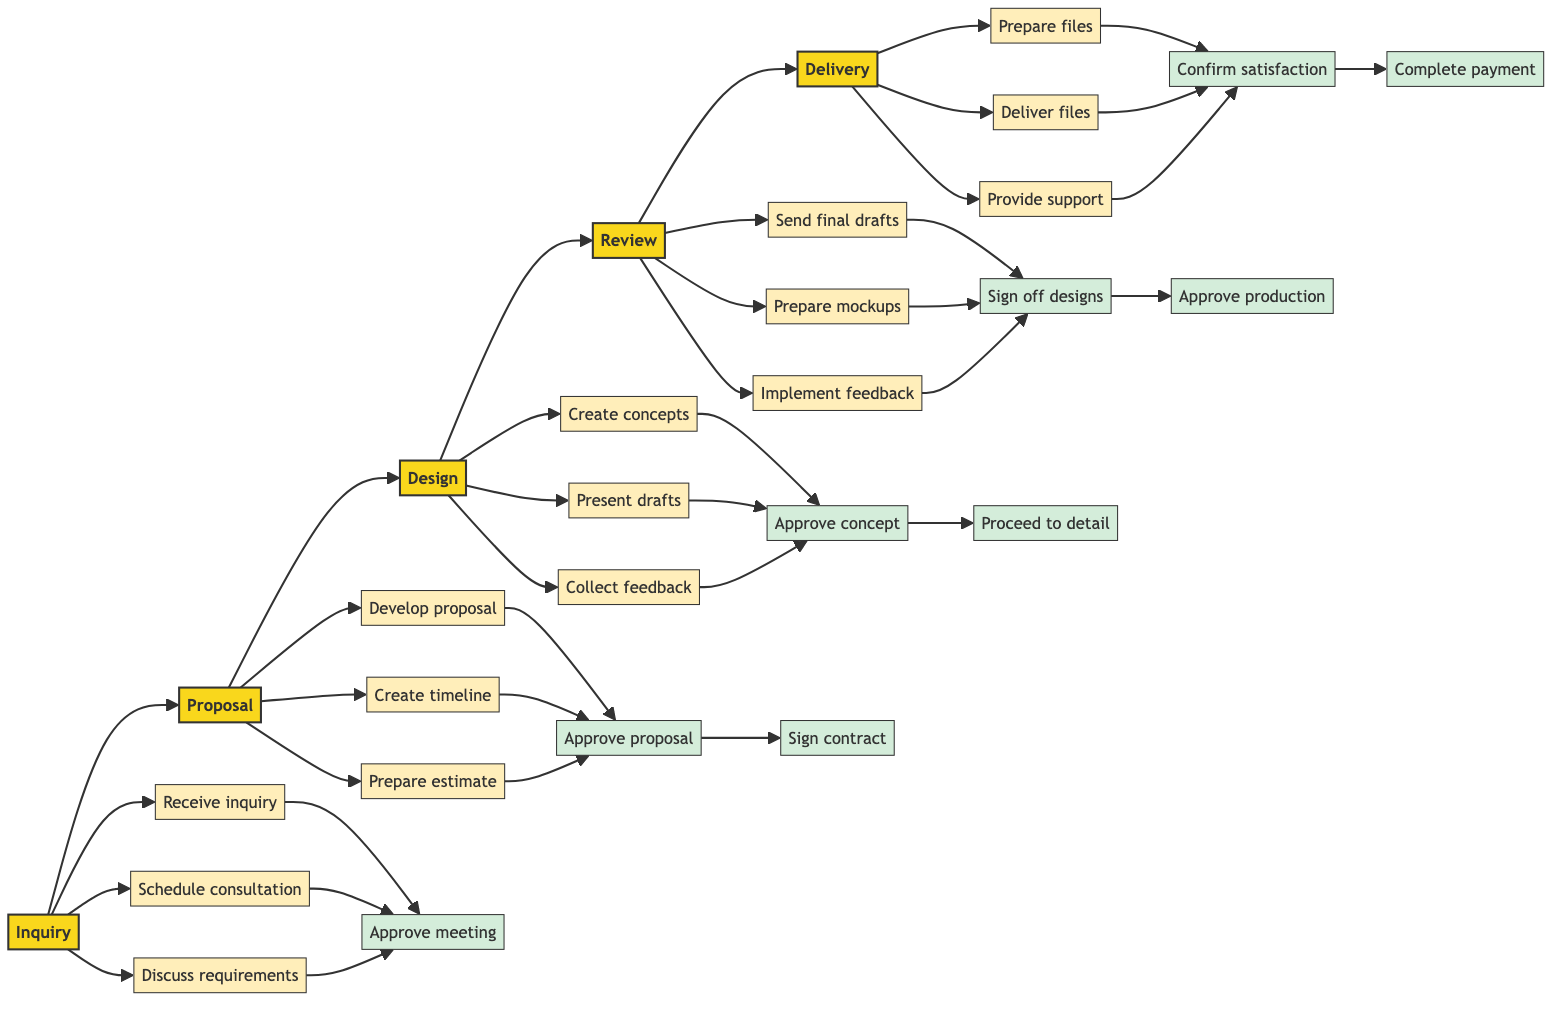What is the first stage in the workflow? The first stage is indicated as "Inquiry" in the flowchart, which is the starting point of the client project workflow.
Answer: Inquiry How many key tasks are there in the Proposal stage? In the Proposal stage, there are three key tasks listed: Develop project proposal, Create project timeline, and Prepare cost estimate. Thus, the total count is three.
Answer: 3 What approval comes after creating design concepts? The approval following the creation of design concepts is the "Client approves final design concept," which allows for proceeding with detailed design work.
Answer: Client approves final design concept Which stage involves preparing mockups or prototypes? The "Review" stage includes the task "Prepare mockups or prototypes if applicable," signifying that this is where mockups are handled.
Answer: Review What two key tasks are in the Delivery stage? In the Delivery stage, the key tasks include "Prepare final design files for delivery" and "Deliver final files to client via agreed method." These tasks focus on finalizing and sending files to the client.
Answer: Prepare final design files for delivery, Deliver final files What approval is required after sending final drafts to the client? Following the "Send final drafts to client for review" task, the required approval is "Client signs off on final designs," which is necessary before moving on to production approval.
Answer: Client signs off on final designs What is the relationship between the Design and Review stages? The Design stage leads directly to the Review stage; specifically, after the client feedback is collected in the Design stage, approval is needed to continue to the Review stage.
Answer: Design leads to Review How many stages are in the entire workflow? The diagram outlines a total of five distinct stages within the client project workflow, indicating a structured process from inquiry to delivery.
Answer: 5 